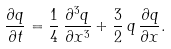<formula> <loc_0><loc_0><loc_500><loc_500>\frac { \partial q } { \partial t } = \frac { 1 } { 4 } \, \frac { { \partial } ^ { 3 } q } { \partial x ^ { 3 } } + \frac { 3 } { 2 } \, q \, \frac { \partial q } { \partial x } .</formula> 